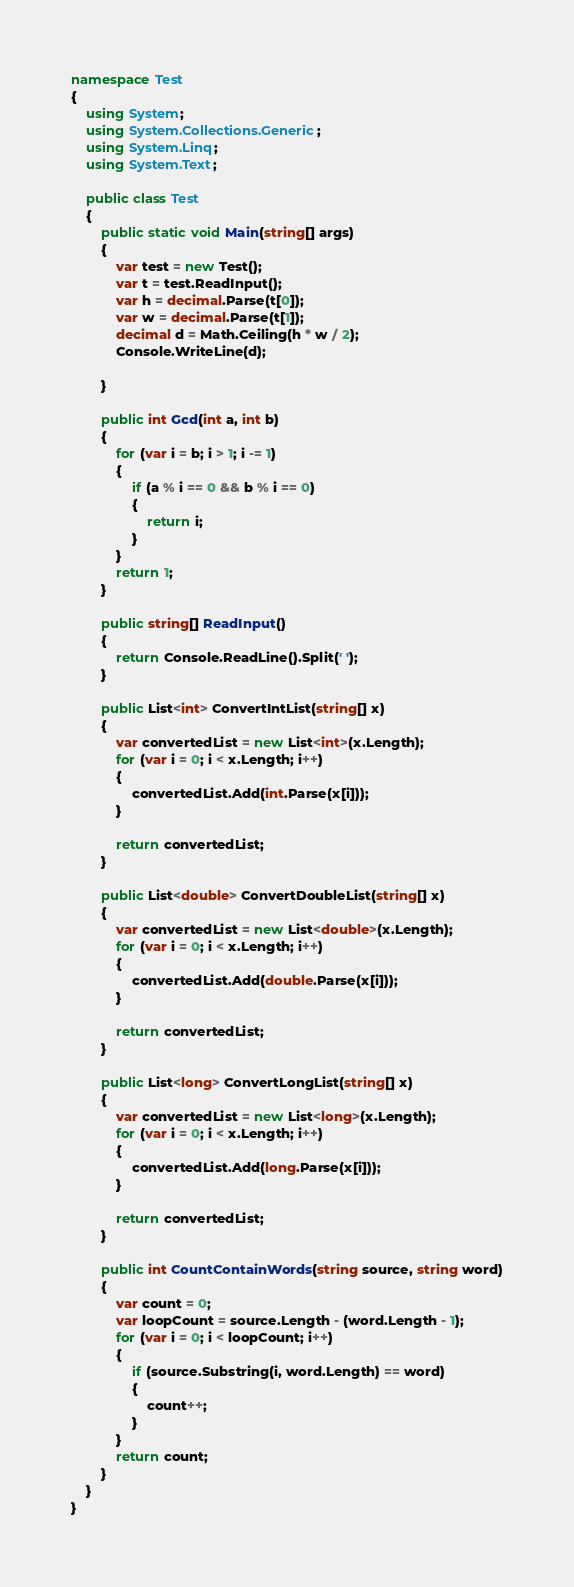Convert code to text. <code><loc_0><loc_0><loc_500><loc_500><_C#_>namespace Test
{
    using System;
    using System.Collections.Generic;
    using System.Linq;
    using System.Text;

    public class Test
    {
        public static void Main(string[] args)
        {
            var test = new Test();
            var t = test.ReadInput();
            var h = decimal.Parse(t[0]);
            var w = decimal.Parse(t[1]);
            decimal d = Math.Ceiling(h * w / 2);
            Console.WriteLine(d);

        }

        public int Gcd(int a, int b)
        {
            for (var i = b; i > 1; i -= 1)
            {
                if (a % i == 0 && b % i == 0)
                {
                    return i;
                }
            }
            return 1;
        }

        public string[] ReadInput()
        {
            return Console.ReadLine().Split(' ');
        }

        public List<int> ConvertIntList(string[] x)
        {
            var convertedList = new List<int>(x.Length);
            for (var i = 0; i < x.Length; i++)
            {
                convertedList.Add(int.Parse(x[i]));
            }

            return convertedList;
        }

        public List<double> ConvertDoubleList(string[] x)
        {
            var convertedList = new List<double>(x.Length);
            for (var i = 0; i < x.Length; i++)
            {
                convertedList.Add(double.Parse(x[i]));
            }

            return convertedList;
        }

        public List<long> ConvertLongList(string[] x)
        {
            var convertedList = new List<long>(x.Length);
            for (var i = 0; i < x.Length; i++)
            {
                convertedList.Add(long.Parse(x[i]));
            }

            return convertedList;
        }

        public int CountContainWords(string source, string word)
        {
            var count = 0;
            var loopCount = source.Length - (word.Length - 1);
            for (var i = 0; i < loopCount; i++)
            {
                if (source.Substring(i, word.Length) == word)
                {
                    count++;
                }
            }
            return count;
        }
    }
}</code> 